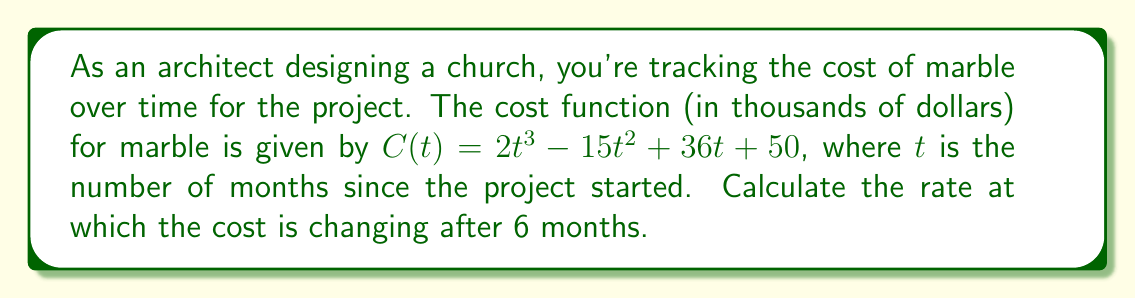Show me your answer to this math problem. To find the rate of change in the cost of marble after 6 months, we need to follow these steps:

1. The rate of change is represented by the derivative of the cost function $C(t)$.

2. Let's find the derivative $C'(t)$:
   $$C'(t) = \frac{d}{dt}(2t^3 - 15t^2 + 36t + 50)$$
   $$C'(t) = 6t^2 - 30t + 36$$

3. Now that we have the derivative, we can calculate the rate of change at $t = 6$ months:
   $$C'(6) = 6(6)^2 - 30(6) + 36$$
   $$C'(6) = 6(36) - 180 + 36$$
   $$C'(6) = 216 - 180 + 36$$
   $$C'(6) = 72$$

4. The units of the result are in thousands of dollars per month, as the original function was in thousands of dollars and $t$ is in months.

Therefore, after 6 months, the cost of marble is changing at a rate of 72 thousand dollars per month.
Answer: $72$ thousand dollars per month 